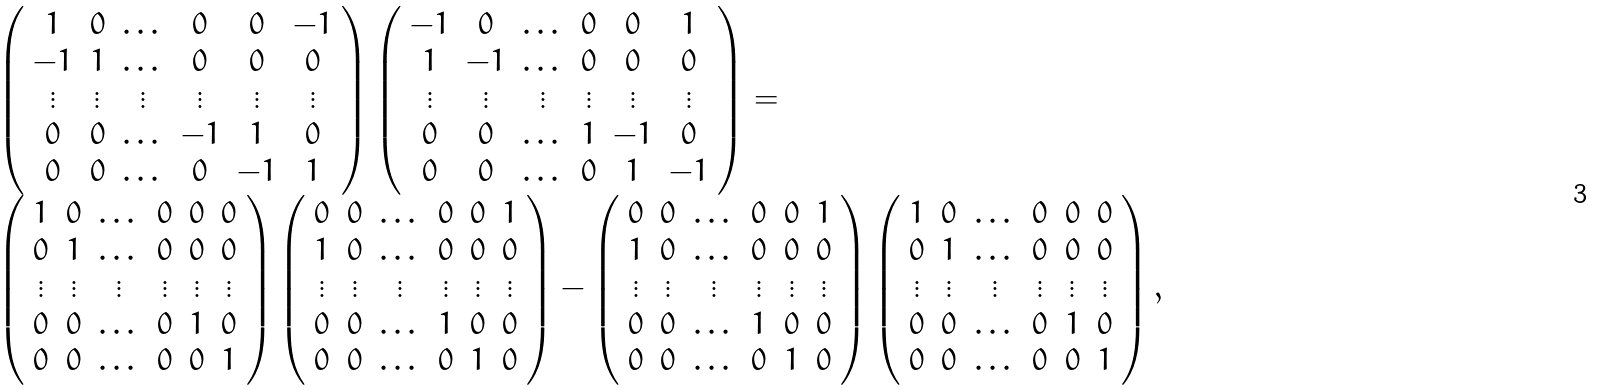<formula> <loc_0><loc_0><loc_500><loc_500>\begin{array} { l } \left ( \begin{array} { c c c c c c } 1 & 0 & \dots & 0 & 0 & - 1 \\ - 1 & 1 & \dots & 0 & 0 & 0 \\ \vdots & \vdots & \vdots & \vdots & \vdots & \vdots \\ 0 & 0 & \dots & - 1 & 1 & 0 \\ 0 & 0 & \dots & 0 & - 1 & 1 \\ \end{array} \right ) \left ( \begin{array} { c c c c c c } - 1 & 0 & \dots & 0 & 0 & 1 \\ 1 & - 1 & \dots & 0 & 0 & 0 \\ \vdots & \vdots & \vdots & \vdots & \vdots & \vdots \\ 0 & 0 & \dots & 1 & - 1 & 0 \\ 0 & 0 & \dots & 0 & 1 & - 1 \\ \end{array} \right ) = \\ \left ( \begin{array} { c c c c c c } 1 & 0 & \dots & 0 & 0 & 0 \\ 0 & 1 & \dots & 0 & 0 & 0 \\ \vdots & \vdots & \vdots & \vdots & \vdots & \vdots \\ 0 & 0 & \dots & 0 & 1 & 0 \\ 0 & 0 & \dots & 0 & 0 & 1 \\ \end{array} \right ) \left ( \begin{array} { c c c c c c } 0 & 0 & \dots & 0 & 0 & 1 \\ 1 & 0 & \dots & 0 & 0 & 0 \\ \vdots & \vdots & \vdots & \vdots & \vdots & \vdots \\ 0 & 0 & \dots & 1 & 0 & 0 \\ 0 & 0 & \dots & 0 & 1 & 0 \\ \end{array} \right ) - \left ( \begin{array} { c c c c c c } 0 & 0 & \dots & 0 & 0 & 1 \\ 1 & 0 & \dots & 0 & 0 & 0 \\ \vdots & \vdots & \vdots & \vdots & \vdots & \vdots \\ 0 & 0 & \dots & 1 & 0 & 0 \\ 0 & 0 & \dots & 0 & 1 & 0 \\ \end{array} \right ) \left ( \begin{array} { c c c c c c } 1 & 0 & \dots & 0 & 0 & 0 \\ 0 & 1 & \dots & 0 & 0 & 0 \\ \vdots & \vdots & \vdots & \vdots & \vdots & \vdots \\ 0 & 0 & \dots & 0 & 1 & 0 \\ 0 & 0 & \dots & 0 & 0 & 1 \\ \end{array} \right ) , \\ \end{array}</formula> 